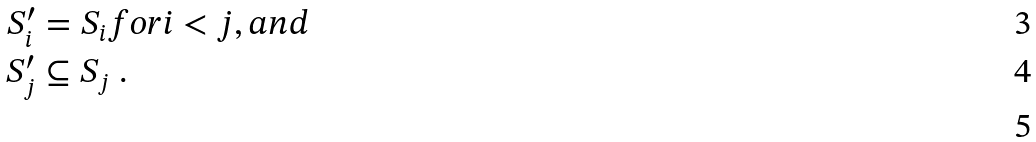Convert formula to latex. <formula><loc_0><loc_0><loc_500><loc_500>S _ { i } ^ { \prime } & = S _ { i } f o r i < j , a n d \\ S _ { j } ^ { \prime } & \subseteq S _ { j } \ . \\</formula> 